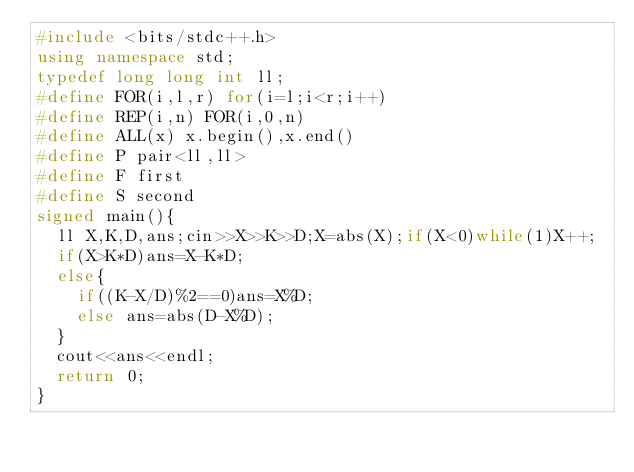Convert code to text. <code><loc_0><loc_0><loc_500><loc_500><_C++_>#include <bits/stdc++.h>
using namespace std;
typedef long long int ll;
#define FOR(i,l,r) for(i=l;i<r;i++)
#define REP(i,n) FOR(i,0,n)
#define ALL(x) x.begin(),x.end()
#define P pair<ll,ll>
#define F first
#define S second
signed main(){
  ll X,K,D,ans;cin>>X>>K>>D;X=abs(X);if(X<0)while(1)X++;
  if(X>K*D)ans=X-K*D;
  else{
    if((K-X/D)%2==0)ans=X%D;
    else ans=abs(D-X%D);
  }
  cout<<ans<<endl;
  return 0;
}</code> 